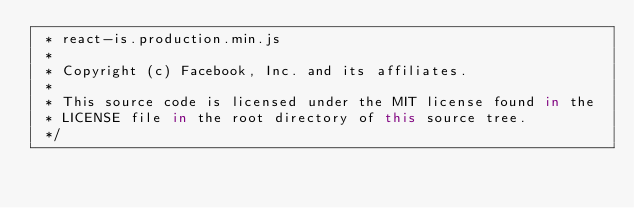<code> <loc_0><loc_0><loc_500><loc_500><_JavaScript_> * react-is.production.min.js
 *
 * Copyright (c) Facebook, Inc. and its affiliates.
 *
 * This source code is licensed under the MIT license found in the
 * LICENSE file in the root directory of this source tree.
 */</code> 